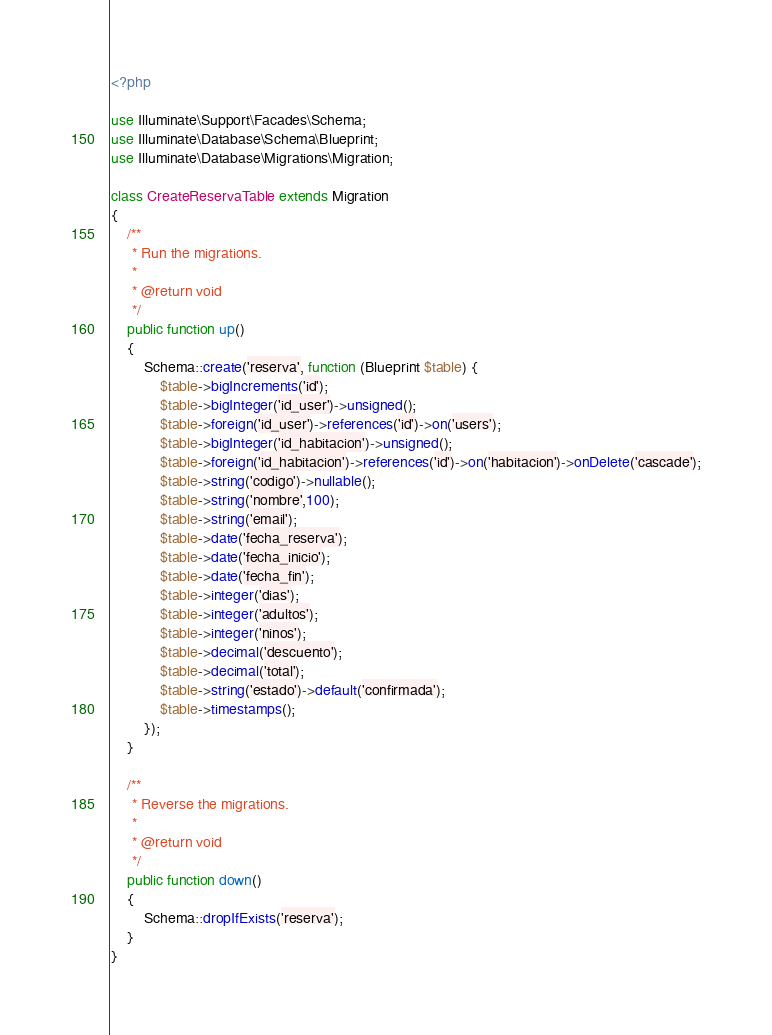Convert code to text. <code><loc_0><loc_0><loc_500><loc_500><_PHP_><?php

use Illuminate\Support\Facades\Schema;
use Illuminate\Database\Schema\Blueprint;
use Illuminate\Database\Migrations\Migration;

class CreateReservaTable extends Migration
{
    /**
     * Run the migrations.
     *
     * @return void
     */
    public function up()
    {
        Schema::create('reserva', function (Blueprint $table) {
            $table->bigIncrements('id');
            $table->bigInteger('id_user')->unsigned();
            $table->foreign('id_user')->references('id')->on('users');
            $table->bigInteger('id_habitacion')->unsigned();
            $table->foreign('id_habitacion')->references('id')->on('habitacion')->onDelete('cascade');
            $table->string('codigo')->nullable();
            $table->string('nombre',100);
            $table->string('email');
            $table->date('fecha_reserva');
            $table->date('fecha_inicio');
            $table->date('fecha_fin');
            $table->integer('dias');
            $table->integer('adultos');
            $table->integer('ninos');
            $table->decimal('descuento');
            $table->decimal('total');
            $table->string('estado')->default('confirmada');
            $table->timestamps();
        });
    }

    /**
     * Reverse the migrations.
     *
     * @return void
     */
    public function down()
    {
        Schema::dropIfExists('reserva');
    }
}
</code> 